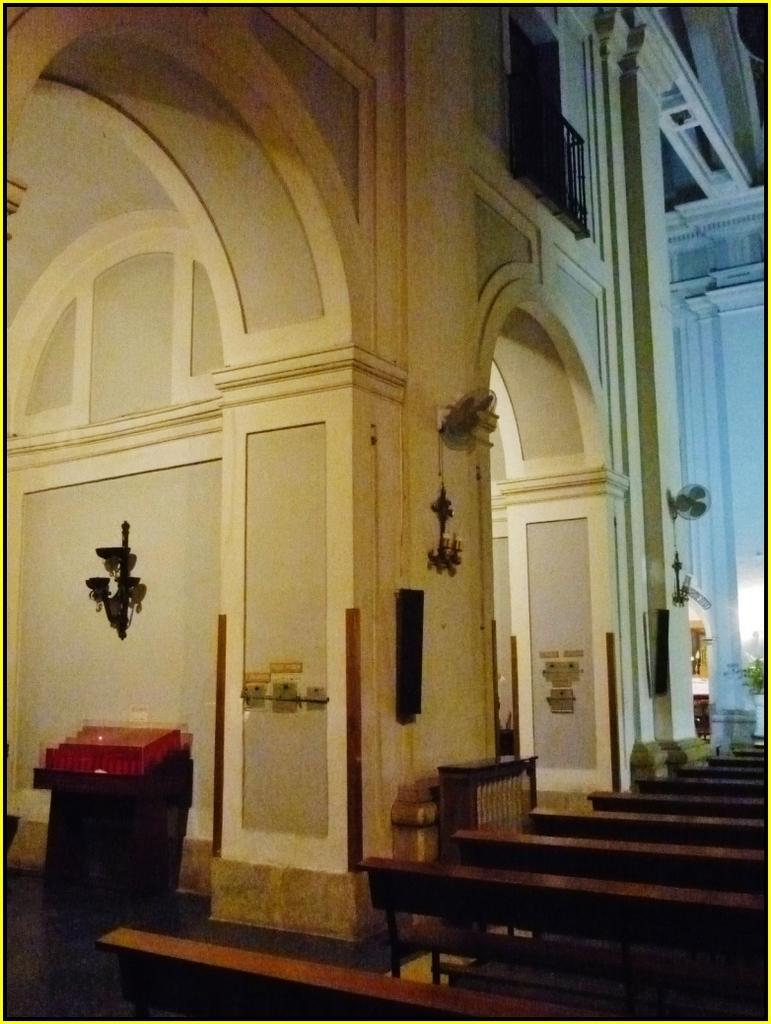What type of location is depicted in the image? The image is an inside view of a building. What structural elements can be seen in the image? There are walls in the image. Are there any decorative elements in the image? Yes, decorative objects are present in the image. What type of furniture is visible in the image? There are benches in the image. What type of cooling device is visible in the image? Table fans are visible in the image. What type of barrier is present in the image? There is a railing in the image. What type of news can be seen on the wall in the image? There is no news present in the image; it is an inside view of a building with walls, decorative objects, benches, table fans, and a railing. What type of tool is being used to cut the railing in the image? There is no tool being used to cut the railing in the image; it is a stationary barrier. 